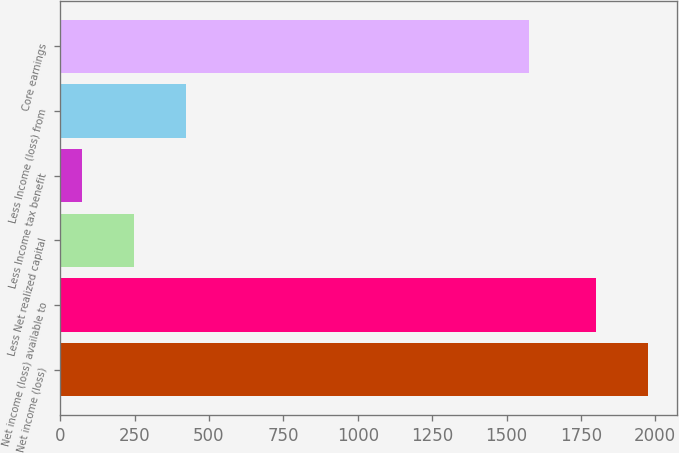Convert chart. <chart><loc_0><loc_0><loc_500><loc_500><bar_chart><fcel>Net income (loss)<fcel>Net income (loss) available to<fcel>Less Net realized capital<fcel>Less Income tax benefit<fcel>Less Income (loss) from<fcel>Core earnings<nl><fcel>1974.2<fcel>1801<fcel>248.2<fcel>75<fcel>421.4<fcel>1575<nl></chart> 